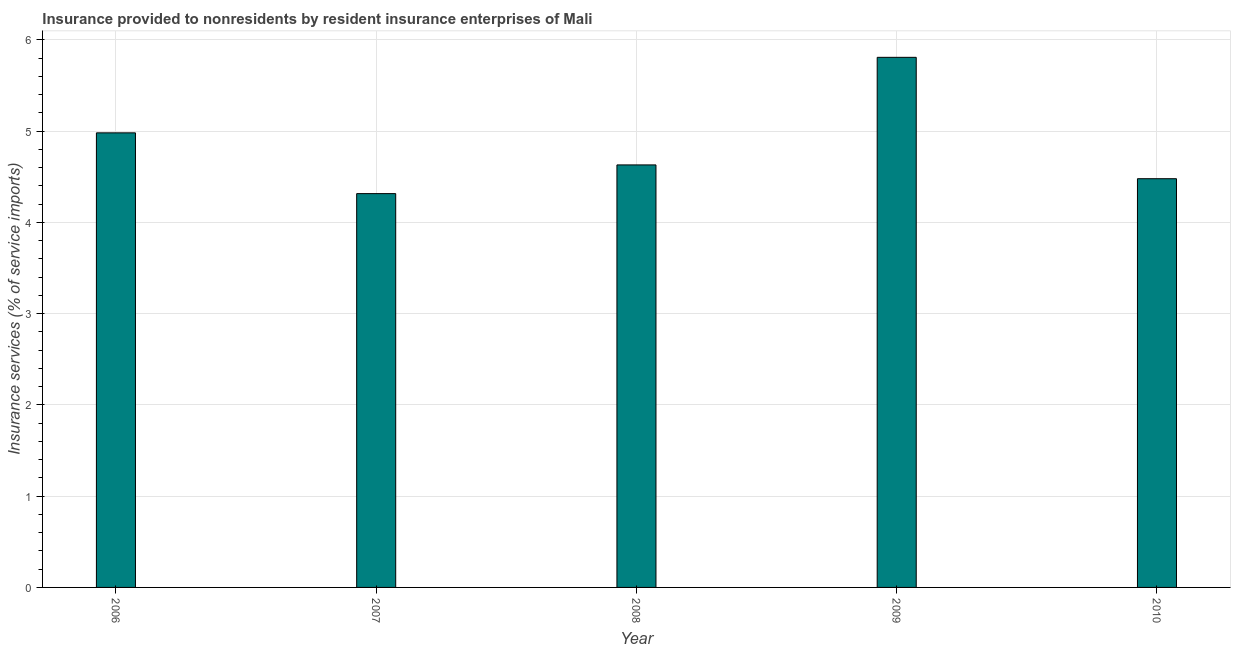Does the graph contain grids?
Provide a succinct answer. Yes. What is the title of the graph?
Offer a very short reply. Insurance provided to nonresidents by resident insurance enterprises of Mali. What is the label or title of the Y-axis?
Give a very brief answer. Insurance services (% of service imports). What is the insurance and financial services in 2010?
Make the answer very short. 4.48. Across all years, what is the maximum insurance and financial services?
Make the answer very short. 5.81. Across all years, what is the minimum insurance and financial services?
Offer a terse response. 4.31. In which year was the insurance and financial services maximum?
Your response must be concise. 2009. What is the sum of the insurance and financial services?
Ensure brevity in your answer.  24.21. What is the difference between the insurance and financial services in 2007 and 2009?
Your answer should be compact. -1.49. What is the average insurance and financial services per year?
Provide a short and direct response. 4.84. What is the median insurance and financial services?
Your response must be concise. 4.63. In how many years, is the insurance and financial services greater than 4.6 %?
Your answer should be very brief. 3. What is the ratio of the insurance and financial services in 2008 to that in 2010?
Your response must be concise. 1.03. Is the insurance and financial services in 2009 less than that in 2010?
Provide a succinct answer. No. What is the difference between the highest and the second highest insurance and financial services?
Your answer should be very brief. 0.83. Is the sum of the insurance and financial services in 2008 and 2010 greater than the maximum insurance and financial services across all years?
Your answer should be compact. Yes. What is the difference between the highest and the lowest insurance and financial services?
Your answer should be compact. 1.49. In how many years, is the insurance and financial services greater than the average insurance and financial services taken over all years?
Your answer should be very brief. 2. Are the values on the major ticks of Y-axis written in scientific E-notation?
Your answer should be compact. No. What is the Insurance services (% of service imports) of 2006?
Your answer should be very brief. 4.98. What is the Insurance services (% of service imports) of 2007?
Give a very brief answer. 4.31. What is the Insurance services (% of service imports) of 2008?
Your response must be concise. 4.63. What is the Insurance services (% of service imports) in 2009?
Keep it short and to the point. 5.81. What is the Insurance services (% of service imports) of 2010?
Give a very brief answer. 4.48. What is the difference between the Insurance services (% of service imports) in 2006 and 2007?
Your answer should be very brief. 0.67. What is the difference between the Insurance services (% of service imports) in 2006 and 2008?
Keep it short and to the point. 0.35. What is the difference between the Insurance services (% of service imports) in 2006 and 2009?
Ensure brevity in your answer.  -0.83. What is the difference between the Insurance services (% of service imports) in 2006 and 2010?
Offer a very short reply. 0.5. What is the difference between the Insurance services (% of service imports) in 2007 and 2008?
Offer a very short reply. -0.31. What is the difference between the Insurance services (% of service imports) in 2007 and 2009?
Your answer should be compact. -1.49. What is the difference between the Insurance services (% of service imports) in 2007 and 2010?
Give a very brief answer. -0.16. What is the difference between the Insurance services (% of service imports) in 2008 and 2009?
Offer a very short reply. -1.18. What is the difference between the Insurance services (% of service imports) in 2008 and 2010?
Your response must be concise. 0.15. What is the difference between the Insurance services (% of service imports) in 2009 and 2010?
Ensure brevity in your answer.  1.33. What is the ratio of the Insurance services (% of service imports) in 2006 to that in 2007?
Provide a succinct answer. 1.15. What is the ratio of the Insurance services (% of service imports) in 2006 to that in 2008?
Offer a very short reply. 1.08. What is the ratio of the Insurance services (% of service imports) in 2006 to that in 2009?
Provide a short and direct response. 0.86. What is the ratio of the Insurance services (% of service imports) in 2006 to that in 2010?
Your response must be concise. 1.11. What is the ratio of the Insurance services (% of service imports) in 2007 to that in 2008?
Offer a terse response. 0.93. What is the ratio of the Insurance services (% of service imports) in 2007 to that in 2009?
Ensure brevity in your answer.  0.74. What is the ratio of the Insurance services (% of service imports) in 2008 to that in 2009?
Provide a short and direct response. 0.8. What is the ratio of the Insurance services (% of service imports) in 2008 to that in 2010?
Your answer should be compact. 1.03. What is the ratio of the Insurance services (% of service imports) in 2009 to that in 2010?
Your response must be concise. 1.3. 